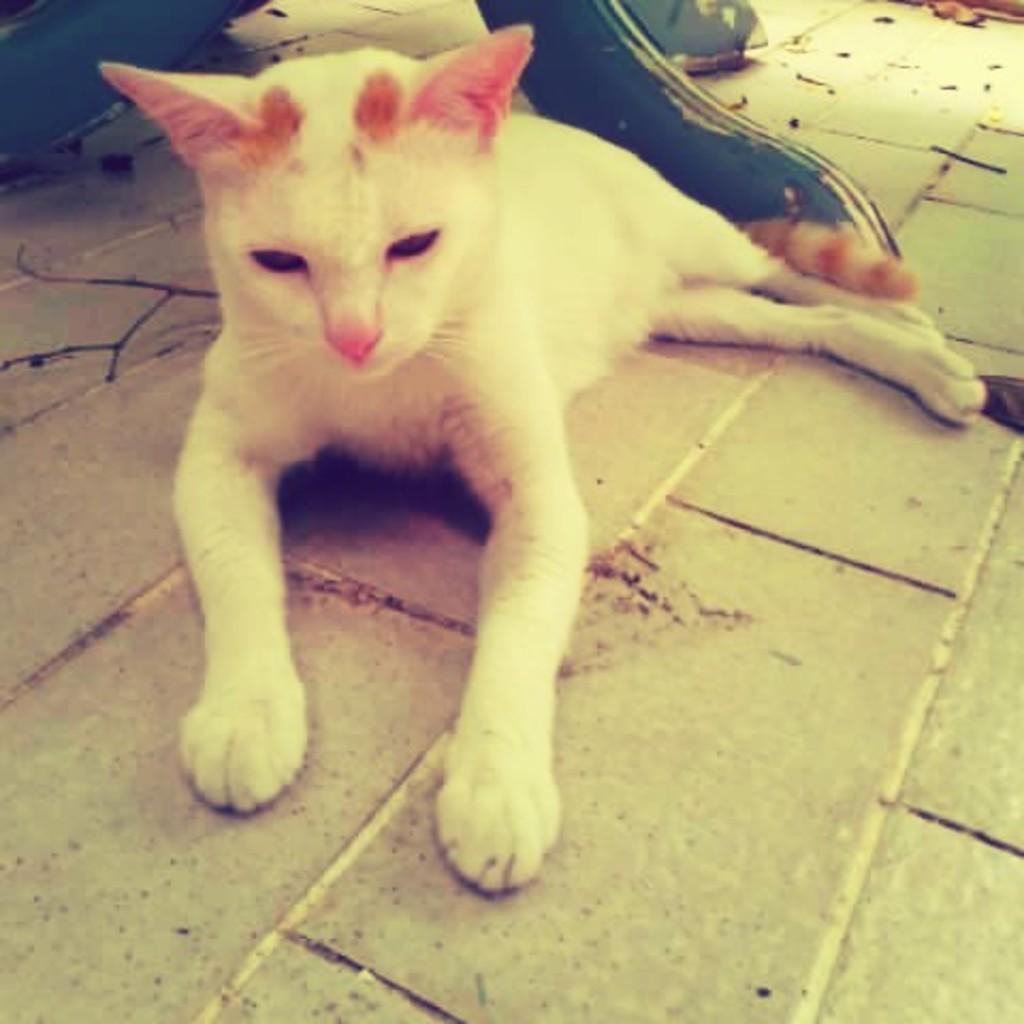What animal is present in the image? There is a cat in the image. What position is the cat in? The cat is lying on the floor. Where is the cat located in the image? The cat is in the center of the image. What type of trousers is the cat wearing in the image? Cats do not wear trousers, so this detail cannot be found in the image. 